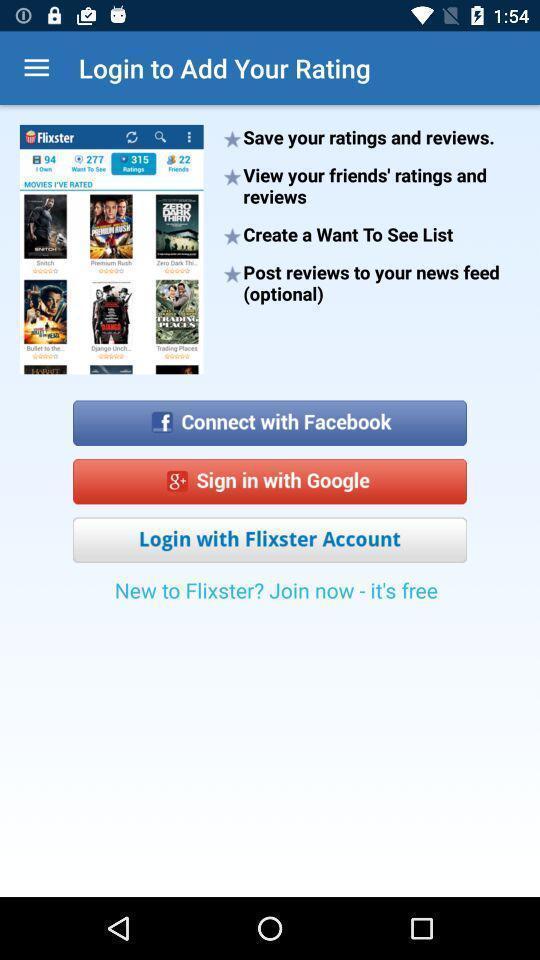Describe this image in words. Welcome to the login page. 